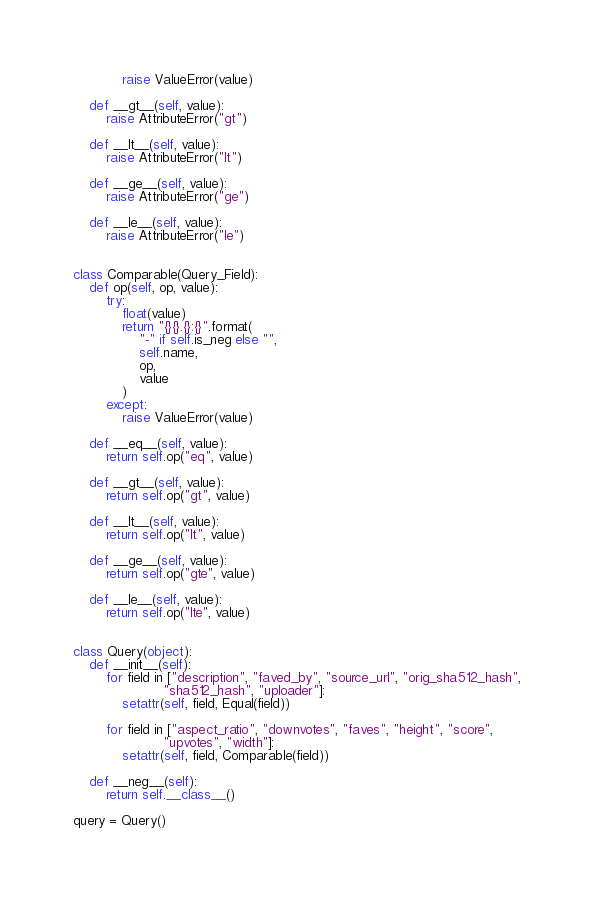<code> <loc_0><loc_0><loc_500><loc_500><_Python_>            raise ValueError(value)

    def __gt__(self, value):
        raise AttributeError("gt")

    def __lt__(self, value):
        raise AttributeError("lt")

    def __ge__(self, value):
        raise AttributeError("ge")

    def __le__(self, value):
        raise AttributeError("le")


class Comparable(Query_Field):
    def op(self, op, value):
        try:
            float(value)
            return "{}{}.{}:{}".format(
                "-" if self.is_neg else "",
                self.name,
                op,
                value
            )
        except:
            raise ValueError(value)

    def __eq__(self, value):
        return self.op("eq", value)

    def __gt__(self, value):
        return self.op("gt", value)

    def __lt__(self, value):
        return self.op("lt", value)

    def __ge__(self, value):
        return self.op("gte", value)

    def __le__(self, value):
        return self.op("lte", value) 


class Query(object):
    def __init__(self):
        for field in ["description", "faved_by", "source_url", "orig_sha512_hash",
                      "sha512_hash", "uploader"]:
            setattr(self, field, Equal(field))

        for field in ["aspect_ratio", "downvotes", "faves", "height", "score",
                      "upvotes", "width"]:
            setattr(self, field, Comparable(field))

    def __neg__(self):
        return self.__class__()

query = Query()
</code> 